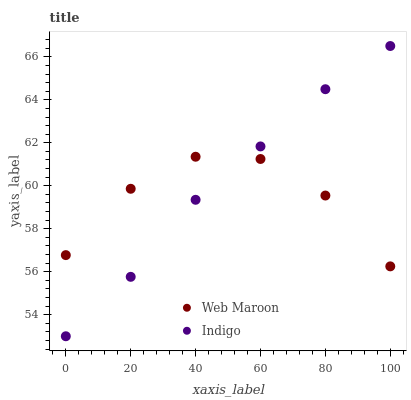Does Web Maroon have the minimum area under the curve?
Answer yes or no. Yes. Does Indigo have the maximum area under the curve?
Answer yes or no. Yes. Does Web Maroon have the maximum area under the curve?
Answer yes or no. No. Is Indigo the smoothest?
Answer yes or no. Yes. Is Web Maroon the roughest?
Answer yes or no. Yes. Is Web Maroon the smoothest?
Answer yes or no. No. Does Indigo have the lowest value?
Answer yes or no. Yes. Does Web Maroon have the lowest value?
Answer yes or no. No. Does Indigo have the highest value?
Answer yes or no. Yes. Does Web Maroon have the highest value?
Answer yes or no. No. Does Indigo intersect Web Maroon?
Answer yes or no. Yes. Is Indigo less than Web Maroon?
Answer yes or no. No. Is Indigo greater than Web Maroon?
Answer yes or no. No. 